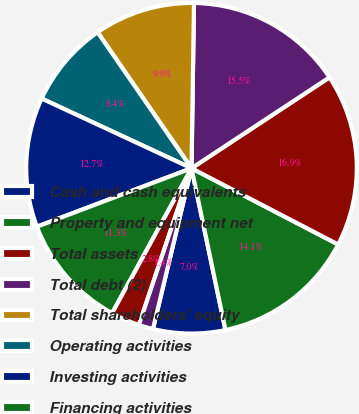Convert chart to OTSL. <chart><loc_0><loc_0><loc_500><loc_500><pie_chart><fcel>Cash and cash equivalents<fcel>Property and equipment net<fcel>Total assets<fcel>Total debt (2)<fcel>Total shareholders' equity<fcel>Operating activities<fcel>Investing activities<fcel>Financing activities<fcel>Towers owned at the beginning<fcel>Towers constructed<nl><fcel>7.04%<fcel>14.08%<fcel>16.9%<fcel>15.49%<fcel>9.86%<fcel>8.45%<fcel>12.68%<fcel>11.27%<fcel>2.82%<fcel>1.41%<nl></chart> 